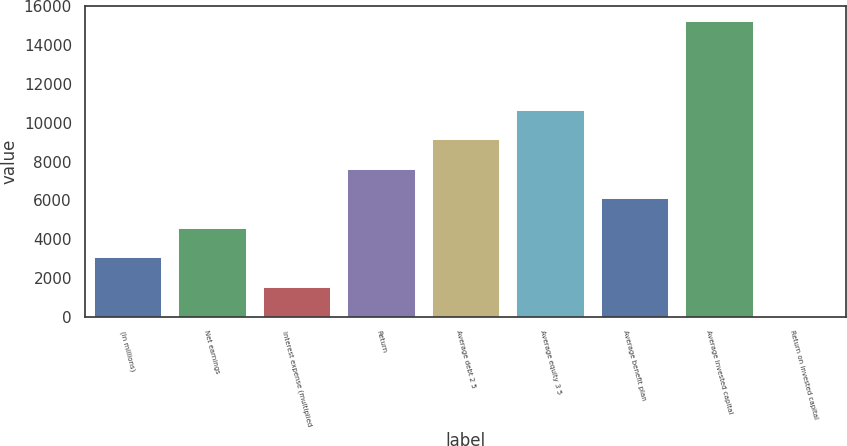Convert chart. <chart><loc_0><loc_0><loc_500><loc_500><bar_chart><fcel>(In millions)<fcel>Net earnings<fcel>Interest expense (multiplied<fcel>Return<fcel>Average debt 2 5<fcel>Average equity 3 5<fcel>Average benefit plan<fcel>Average invested capital<fcel>Return on invested capital<nl><fcel>3066.72<fcel>4589.38<fcel>1544.06<fcel>7634.7<fcel>9157.36<fcel>10680<fcel>6112.04<fcel>15248<fcel>21.4<nl></chart> 